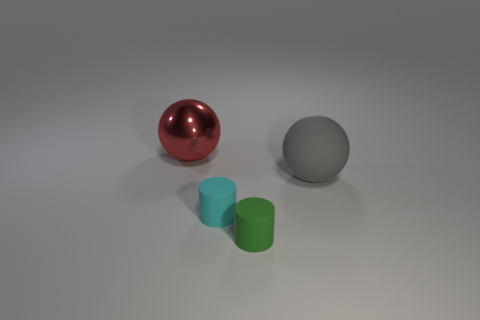Subtract all yellow cylinders. Subtract all green cubes. How many cylinders are left? 2 Add 4 large gray things. How many objects exist? 8 Add 1 big red metal balls. How many big red metal balls exist? 2 Subtract 0 gray cubes. How many objects are left? 4 Subtract all tiny gray balls. Subtract all big red metallic things. How many objects are left? 3 Add 2 large things. How many large things are left? 4 